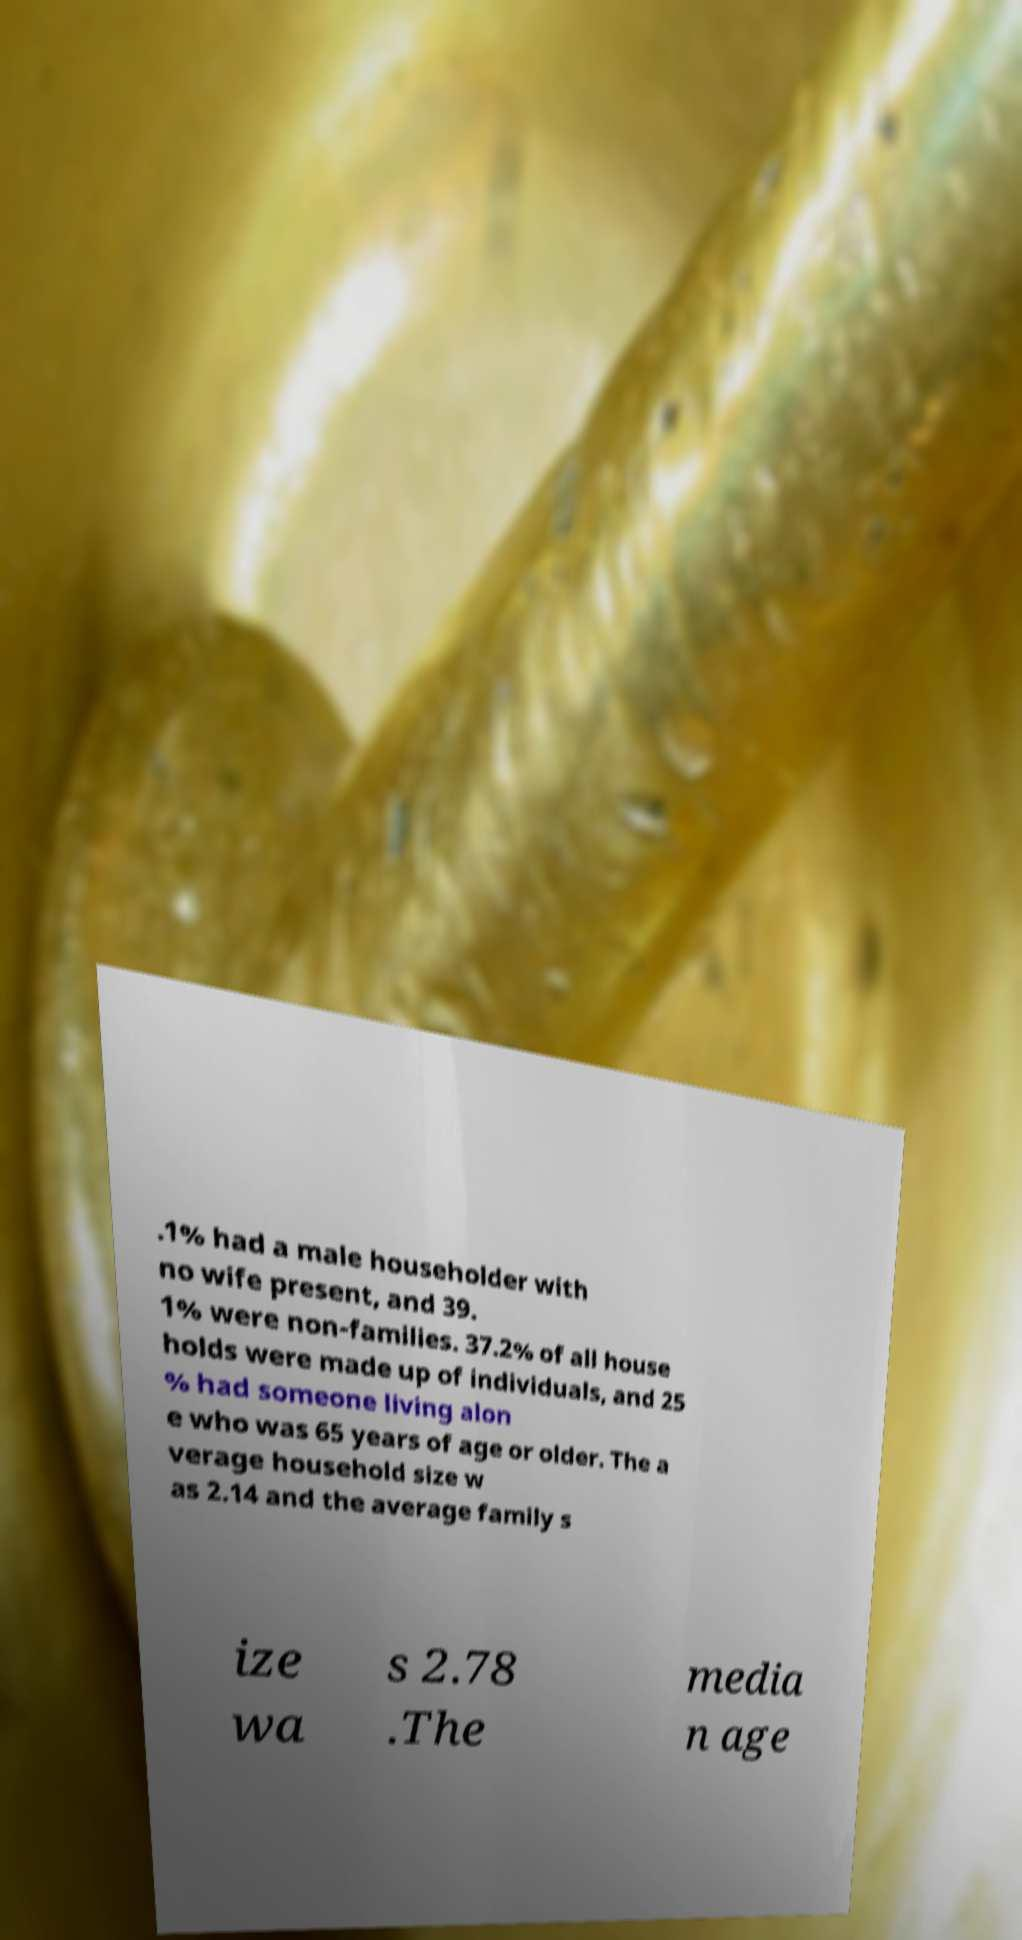Please read and relay the text visible in this image. What does it say? .1% had a male householder with no wife present, and 39. 1% were non-families. 37.2% of all house holds were made up of individuals, and 25 % had someone living alon e who was 65 years of age or older. The a verage household size w as 2.14 and the average family s ize wa s 2.78 .The media n age 